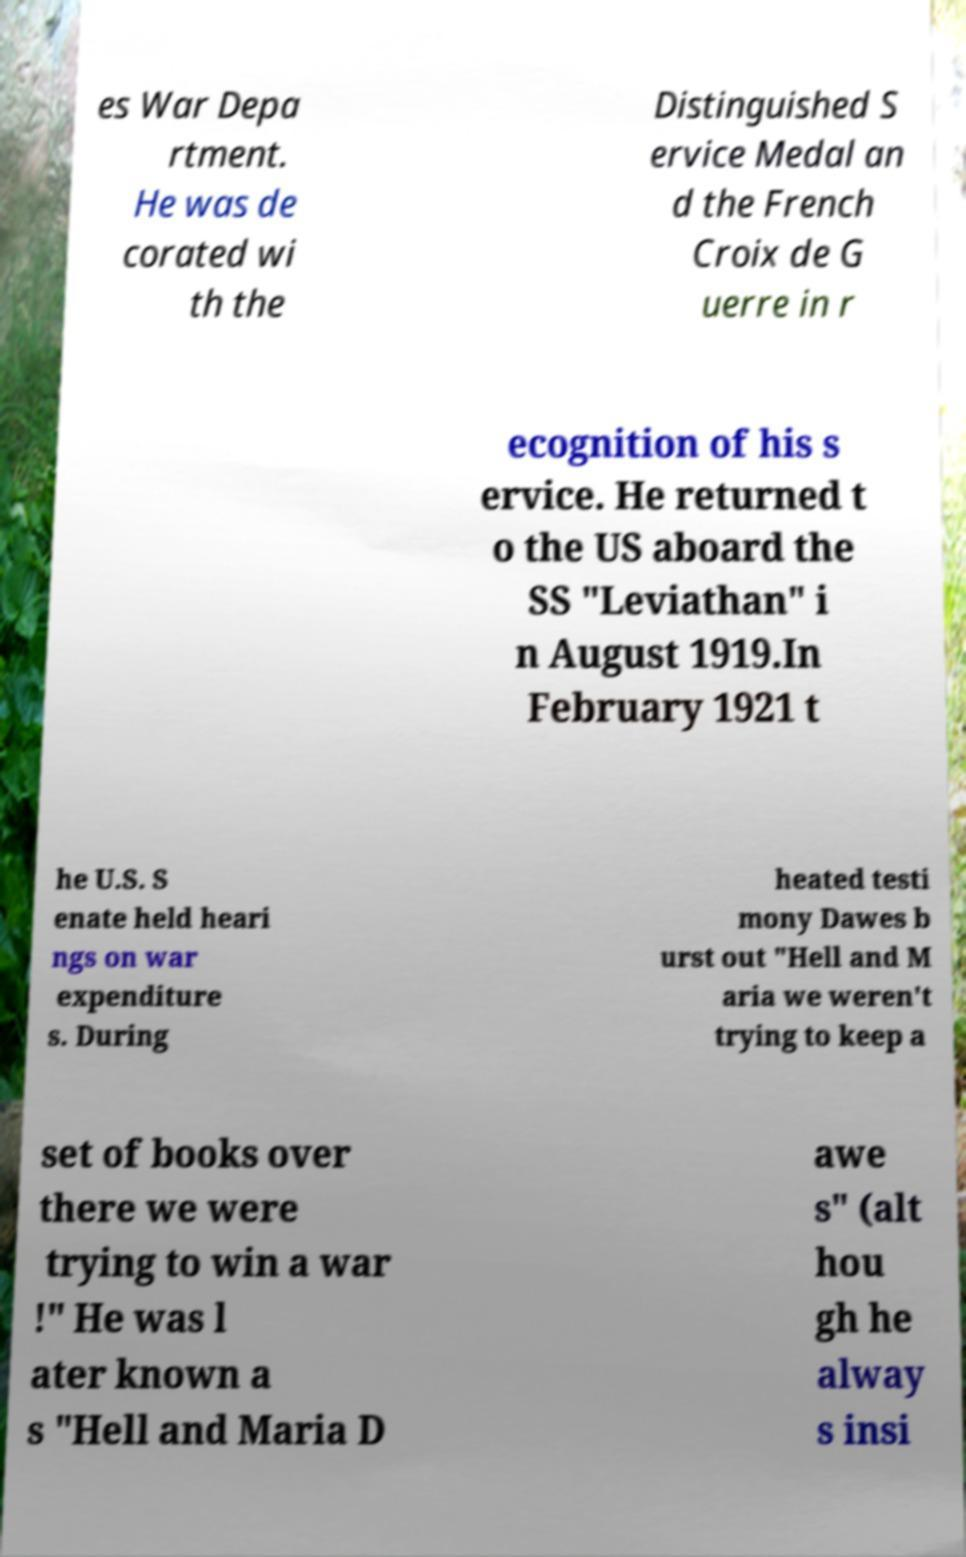Can you read and provide the text displayed in the image?This photo seems to have some interesting text. Can you extract and type it out for me? es War Depa rtment. He was de corated wi th the Distinguished S ervice Medal an d the French Croix de G uerre in r ecognition of his s ervice. He returned t o the US aboard the SS "Leviathan" i n August 1919.In February 1921 t he U.S. S enate held heari ngs on war expenditure s. During heated testi mony Dawes b urst out "Hell and M aria we weren't trying to keep a set of books over there we were trying to win a war !" He was l ater known a s "Hell and Maria D awe s" (alt hou gh he alway s insi 